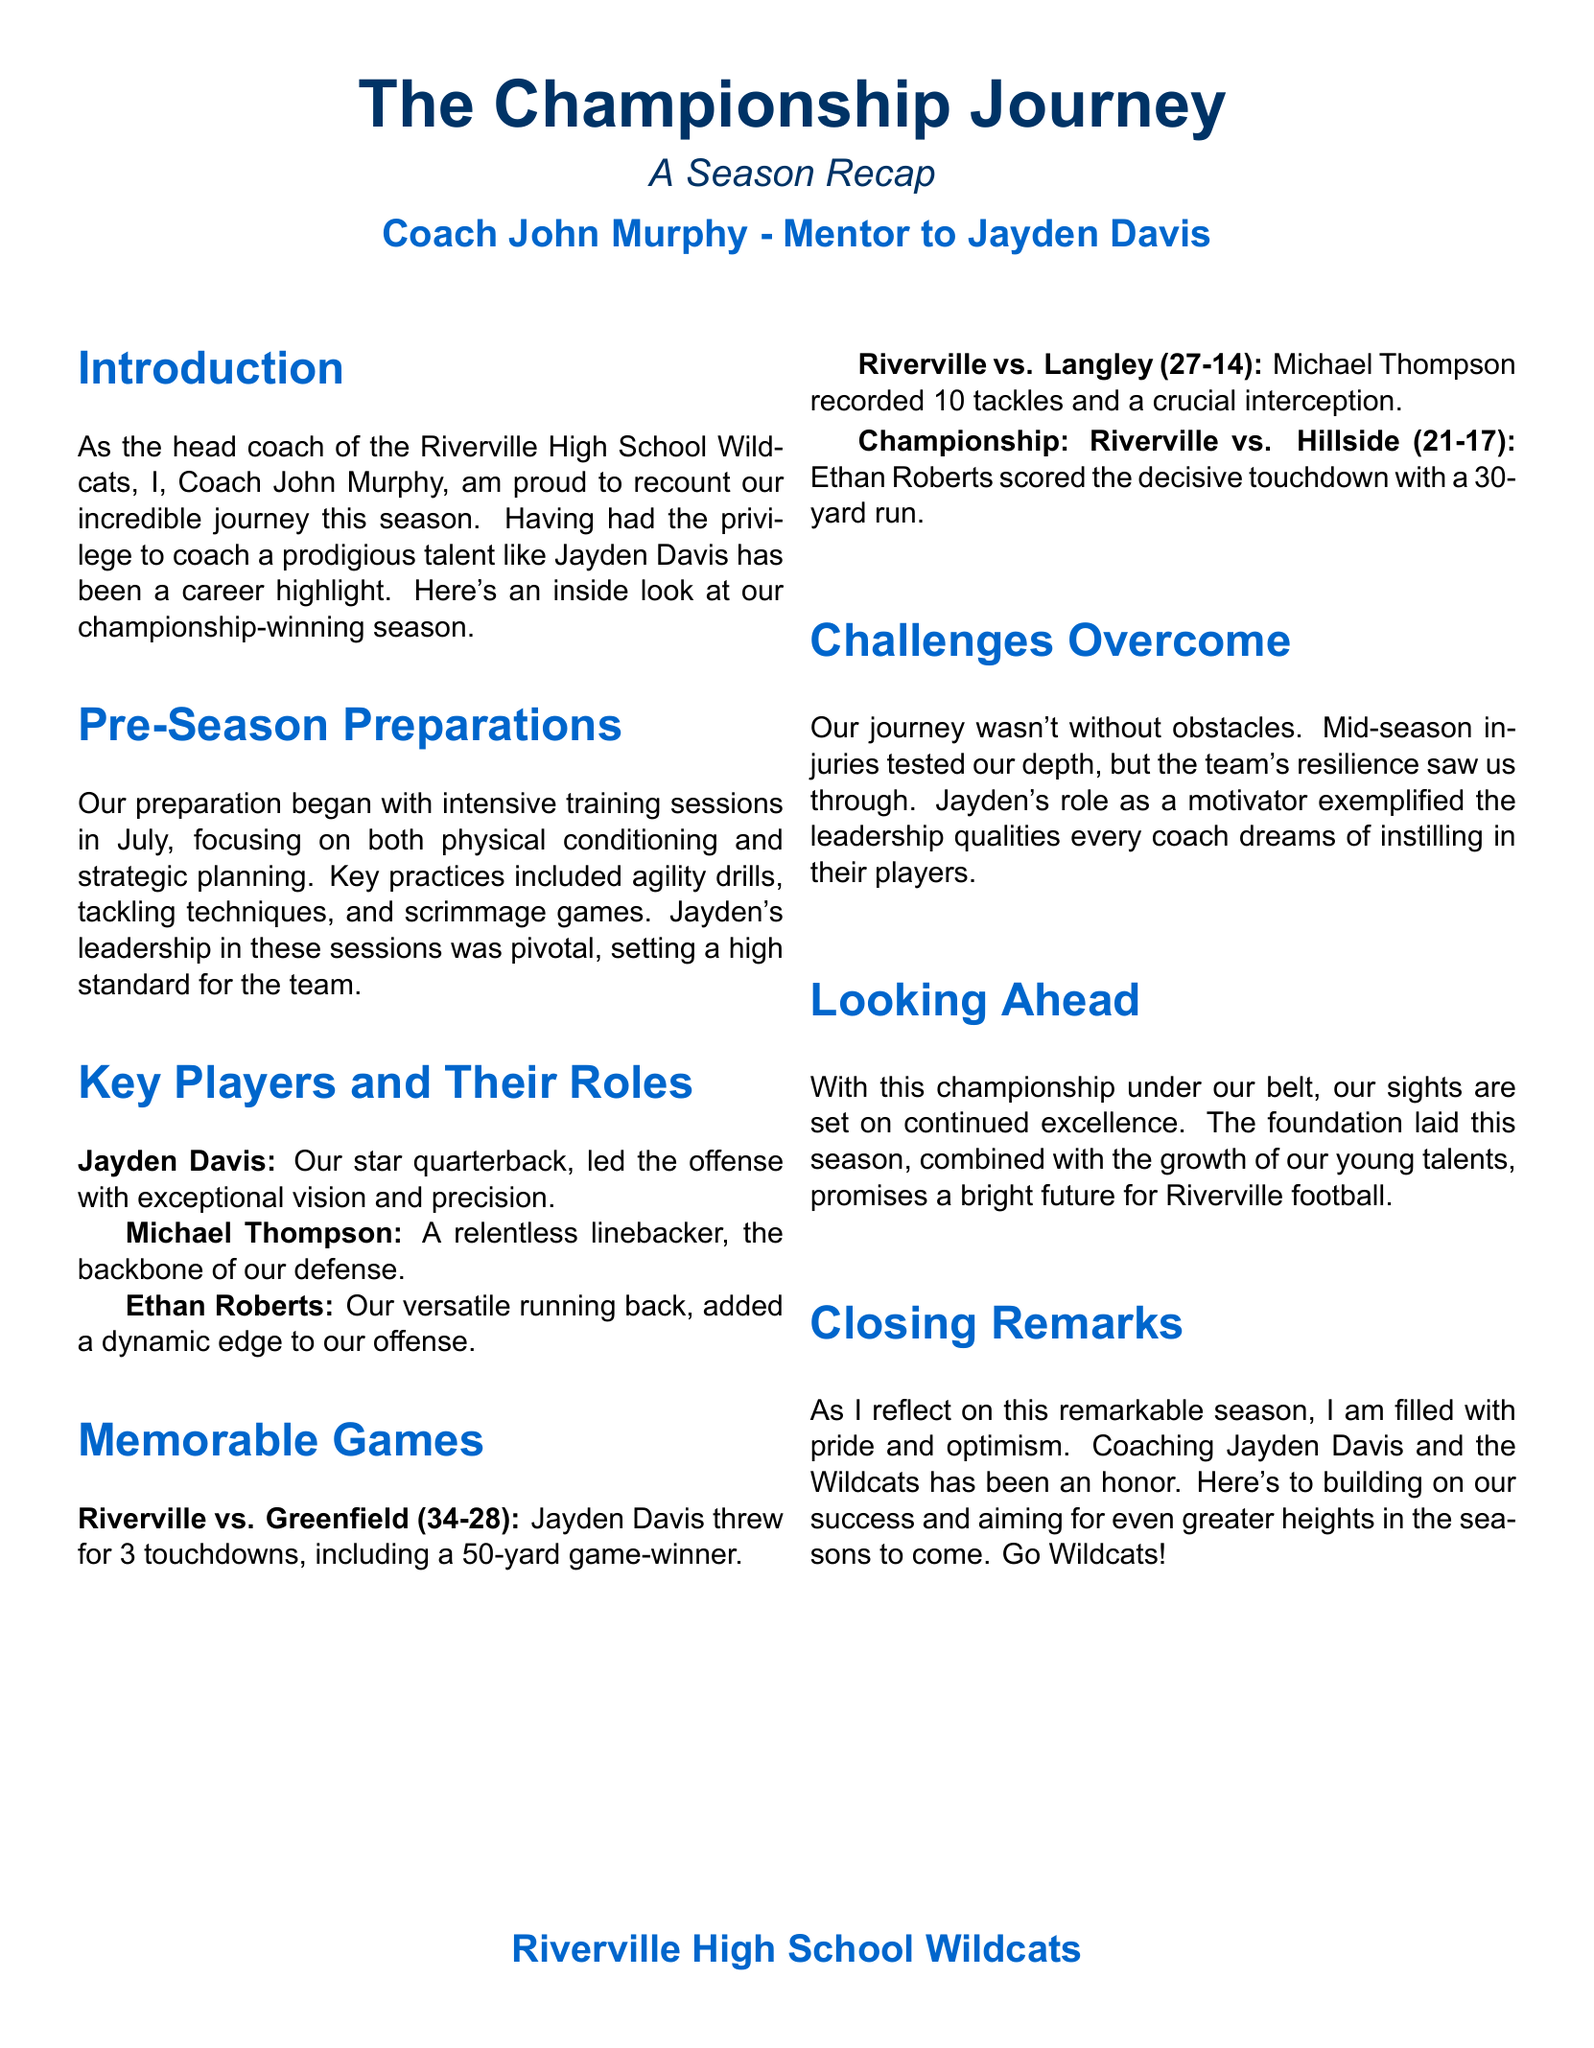What is the title of the document? The title is the main subject of the document, as provided at the beginning, which is "The Championship Journey."
Answer: The Championship Journey Who is the head coach mentioned in the document? The document clearly states the name of the head coach under the introduction section.
Answer: Coach John Murphy In which month did the pre-season training begin? The document specifies that the training sessions began in July.
Answer: July What was the final score of the championship game? The document provides the scoring details of the championship game in the "Memorable Games" section.
Answer: 21-17 How many touchdowns did Jayden Davis throw in the game against Greenfield? The document indicates the number of touchdowns thrown by Jayden Davis in that specific game.
Answer: 3 touchdowns What role did Jayden Davis play on the team? The document describes Jayden Davis's position and contributions in the section about key players.
Answer: Quarterback What challenge did the team face during the season? The document mentions a specific challenge that tested the team's capabilities during the season.
Answer: Injuries What is the team's future focus according to the document? The end section of the document outlines the aspirations for the team's future.
Answer: Continued excellence 